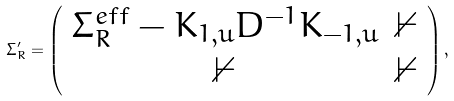Convert formula to latex. <formula><loc_0><loc_0><loc_500><loc_500>\Sigma _ { R } ^ { \prime } = \left ( \begin{array} { c c } \Sigma _ { R } ^ { e f f } - K _ { 1 , u } D ^ { - 1 } K _ { - 1 , u } & \mathbb { 0 } \\ \mathbb { 0 } & \mathbb { 0 } \end{array} \right ) ,</formula> 